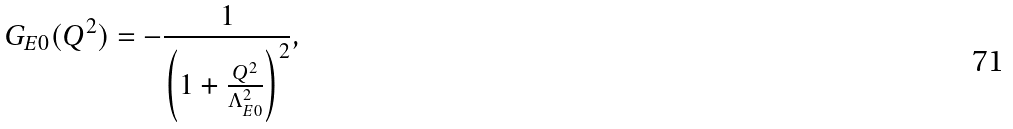<formula> <loc_0><loc_0><loc_500><loc_500>G _ { E 0 } ( Q ^ { 2 } ) & = - \frac { 1 } { \left ( 1 + \frac { Q ^ { 2 } } { \Lambda _ { E 0 } ^ { 2 } } \right ) ^ { 2 } } ,</formula> 